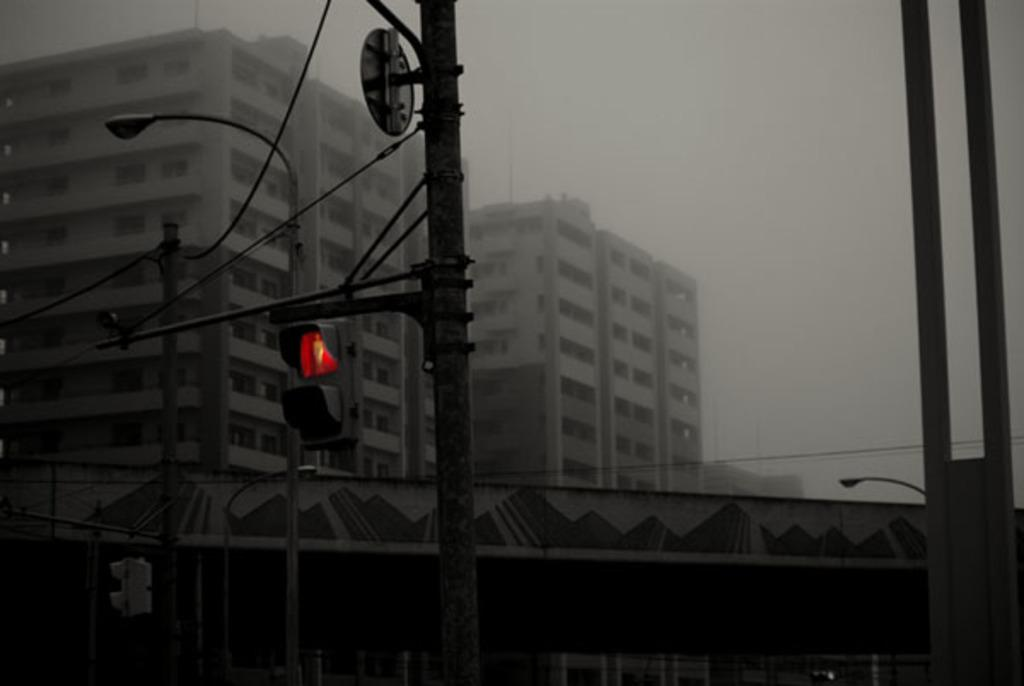What type of infrastructure is present in the image? There are traffic lights, poles, and buildings in the image. Can you describe the cables visible in the image? Yes, there are cables visible in the image. What might the poles be supporting in the image? The poles might be supporting the traffic lights and cables in the image. What type of linen can be seen hanging from the buildings in the image? There is no linen visible in the image; it only features traffic lights, poles, buildings, and cables. How many chickens are present in the image? There are no chickens present in the image. 